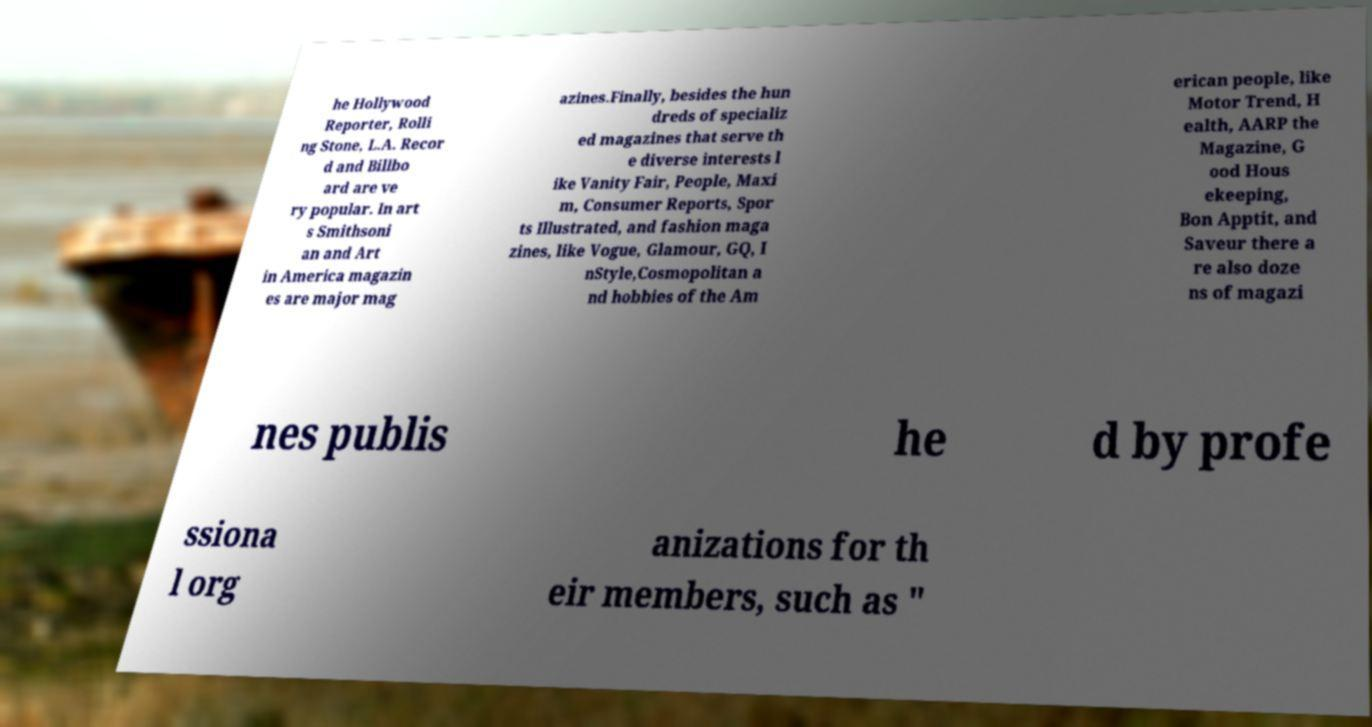There's text embedded in this image that I need extracted. Can you transcribe it verbatim? he Hollywood Reporter, Rolli ng Stone, L.A. Recor d and Billbo ard are ve ry popular. In art s Smithsoni an and Art in America magazin es are major mag azines.Finally, besides the hun dreds of specializ ed magazines that serve th e diverse interests l ike Vanity Fair, People, Maxi m, Consumer Reports, Spor ts Illustrated, and fashion maga zines, like Vogue, Glamour, GQ, I nStyle,Cosmopolitan a nd hobbies of the Am erican people, like Motor Trend, H ealth, AARP the Magazine, G ood Hous ekeeping, Bon Apptit, and Saveur there a re also doze ns of magazi nes publis he d by profe ssiona l org anizations for th eir members, such as " 